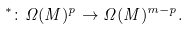Convert formula to latex. <formula><loc_0><loc_0><loc_500><loc_500>^ { * } \colon \Omega ( M ) ^ { p } \rightarrow \Omega ( M ) ^ { m - p } .</formula> 